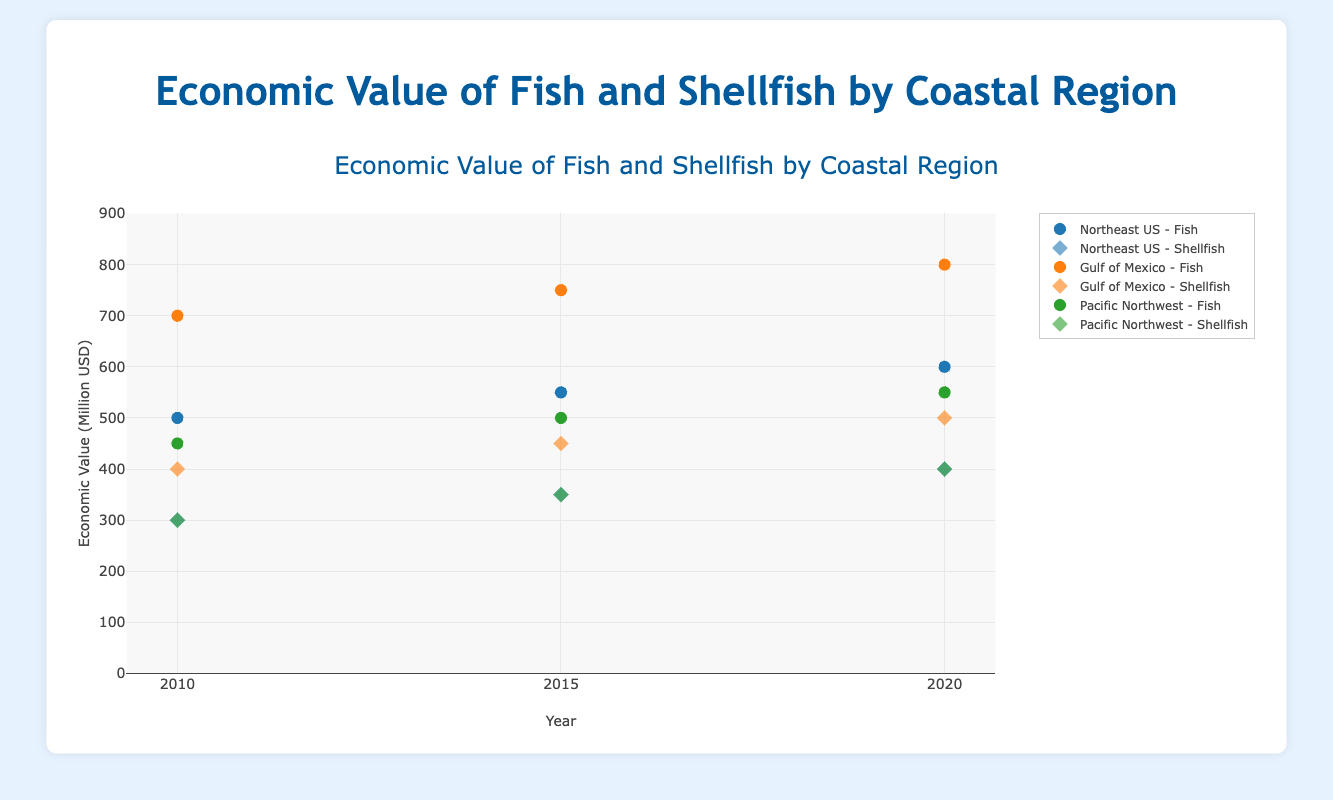What's the title of the plot? The title is displayed at the top of the plot. It reads "Economic Value of Fish and Shellfish by Coastal Region".
Answer: Economic Value of Fish and Shellfish by Coastal Region Which region had the highest economic value for fish in 2010? Look for the highest data point under "Fish" in 2010. The highest value in 2010 for fish is 700 million USD in the Gulf of Mexico.
Answer: Gulf of Mexico How did the economic value of shellfish in the Northeast US change from 2010 to 2020? Track the shellfish data points for the Northeast US from 2010 (300 million USD) to 2020 (400 million USD). The economic value increased.
Answer: Increased What region had the lowest economic value for fish in 2020? Find the lowest data point in 2020 for fish by comparing the values across all regions. The Pacific Northwest had the lowest value at 550 million USD.
Answer: Pacific Northwest What is the average economic value of fish in the Gulf of Mexico across all years? Add the values for fish in Gulf of Mexico for 2010 (700 million USD), 2015 (750 million USD), and 2020 (800 million USD) and divide by 3. (700 + 750 + 800) / 3 = 750 million USD.
Answer: 750 million USD Compare the economic value of shellfish between the Gulf of Mexico and Northeast US in 2020. Which region had a higher value? In 2020, the Gulf of Mexico had a value of 500 million USD for shellfish, while the Northeast US had a value of 400 million USD. The Gulf of Mexico had a higher value.
Answer: Gulf of Mexico Which type (Fish or Shellfish) showed a consistent increase in economic value in the Northeast US from 2010 to 2020? Check both Fish and Shellfish data for the Northeast US in 2010, 2015, and 2020. Fish value increased consistently from 500 to 550 to 600 million USD, while Shellfish also increased from 300 to 350 to 400 million USD. Thus, both showed consistent increase.
Answer: Both What's the difference in economic value of fish between the Pacific Northwest and Gulf of Mexico in 2015? Subtract the Pacific Northwest value (500 million USD) from the Gulf of Mexico value (750 million USD) in 2015. 750 - 500 = 250 million USD.
Answer: 250 million USD How many data points are there for the economic value of fish across all regions and years? Count the number of data points related to fish across the years 2010, 2015, and 2020. There are 3 regions each with 3 years of data (Northeast US, Gulf of Mexico, Pacific Northwest) = 9 data points.
Answer: 9 In which year did the Pacific Northwest see the same economic value for both fish and shellfish? Compare the values for fish and shellfish in the Pacific Northwest across all years (2010, 2015, 2020). Both fish and shellfish had an economic value of 400 million USD in 2020.
Answer: 2020 